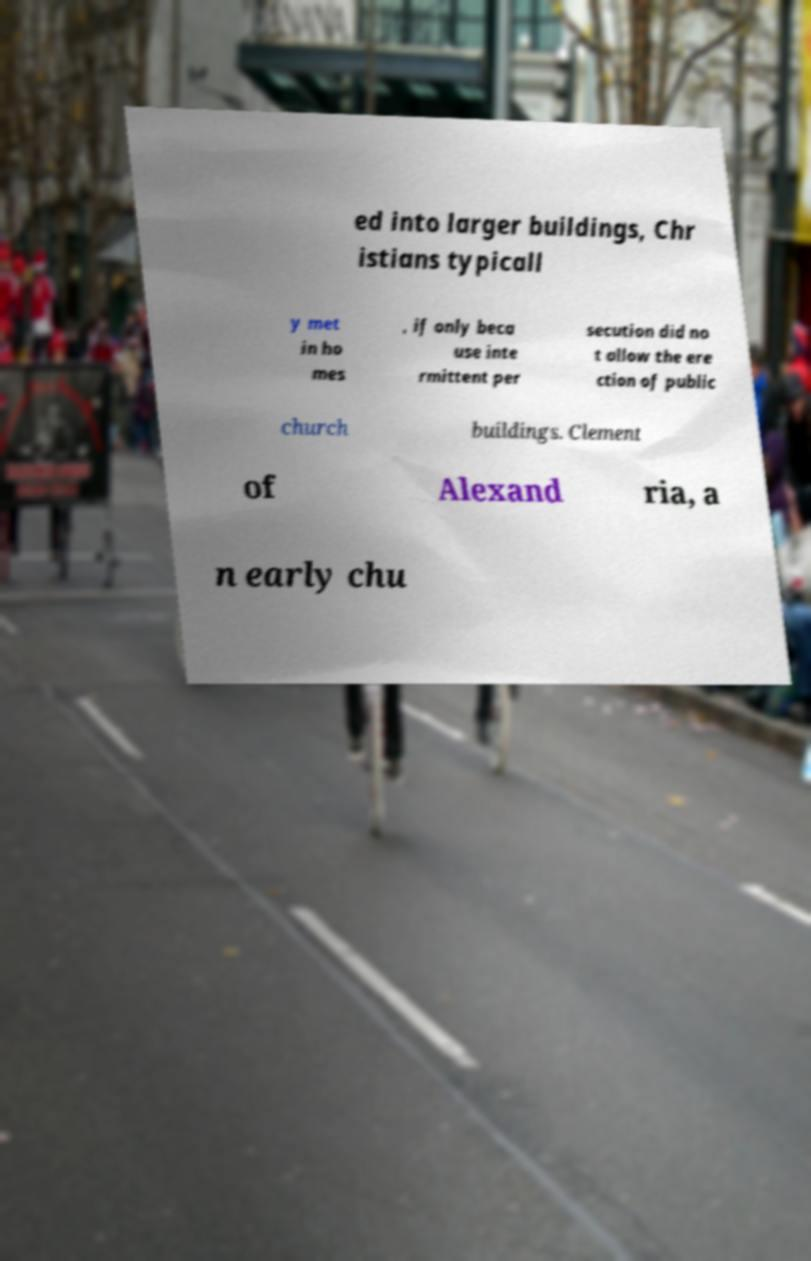There's text embedded in this image that I need extracted. Can you transcribe it verbatim? ed into larger buildings, Chr istians typicall y met in ho mes , if only beca use inte rmittent per secution did no t allow the ere ction of public church buildings. Clement of Alexand ria, a n early chu 